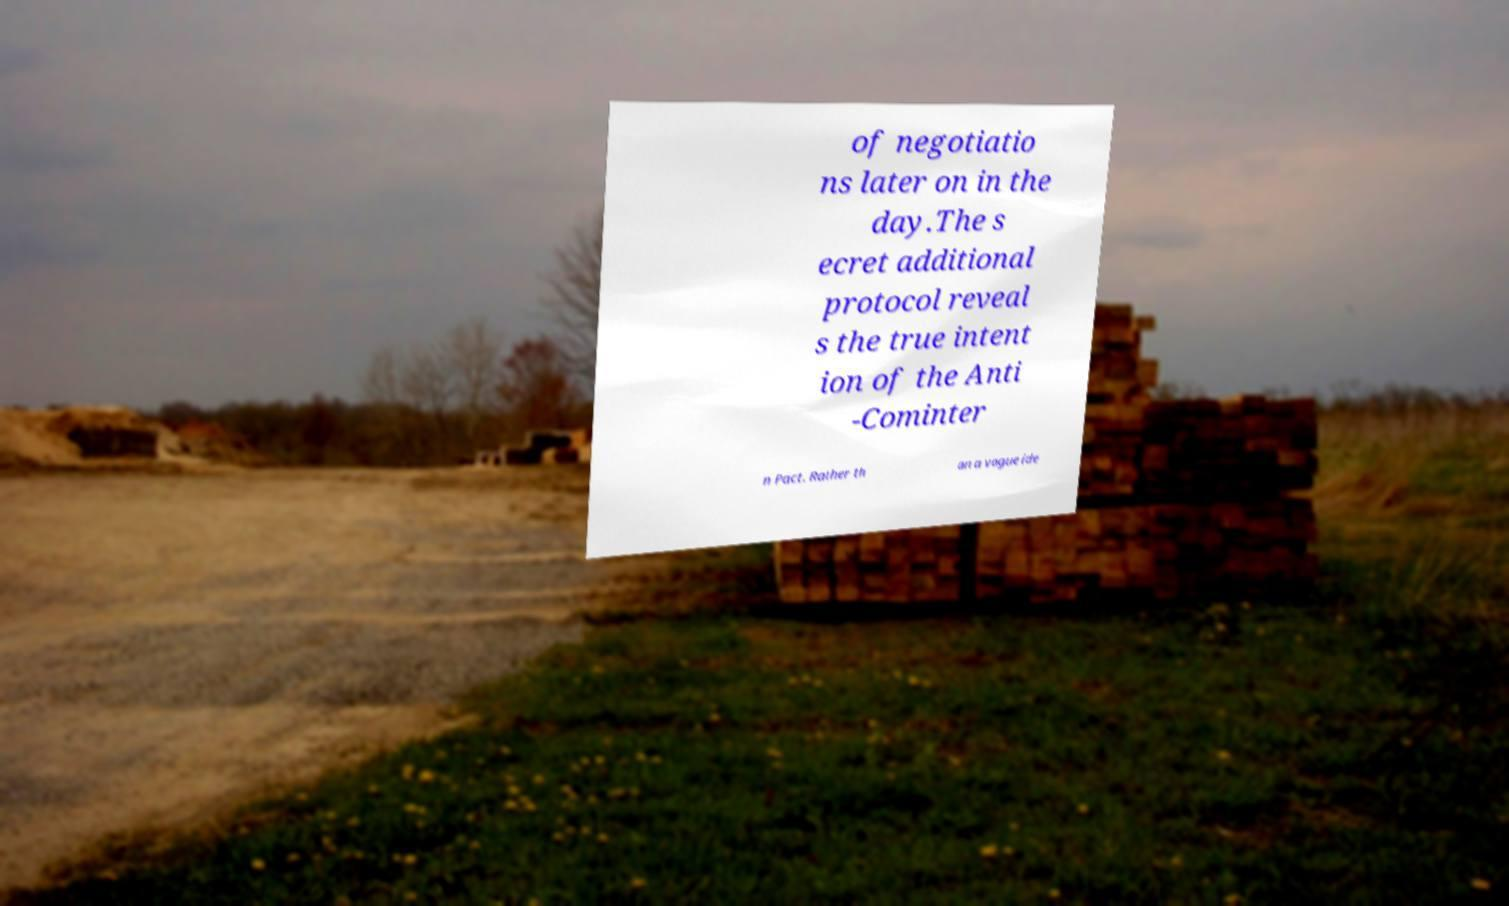There's text embedded in this image that I need extracted. Can you transcribe it verbatim? of negotiatio ns later on in the day.The s ecret additional protocol reveal s the true intent ion of the Anti -Cominter n Pact. Rather th an a vague ide 